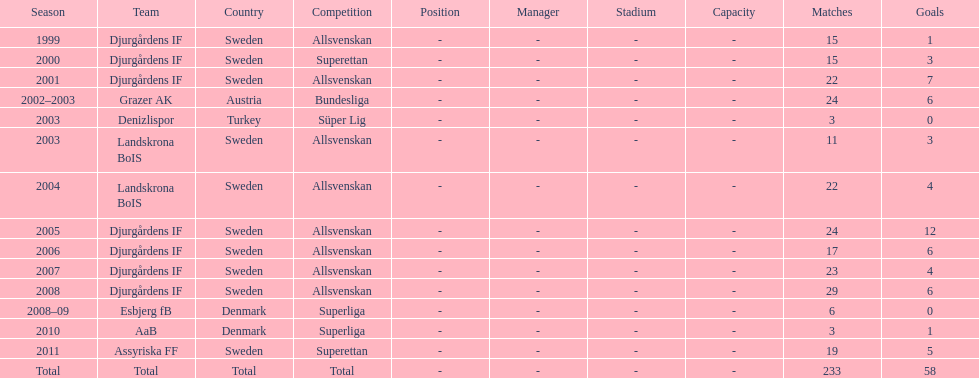What team has the most goals? Djurgårdens IF. 